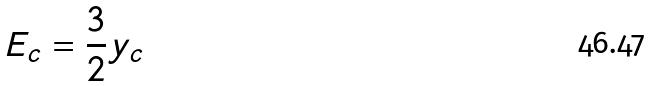<formula> <loc_0><loc_0><loc_500><loc_500>E _ { c } = \frac { 3 } { 2 } y _ { c }</formula> 